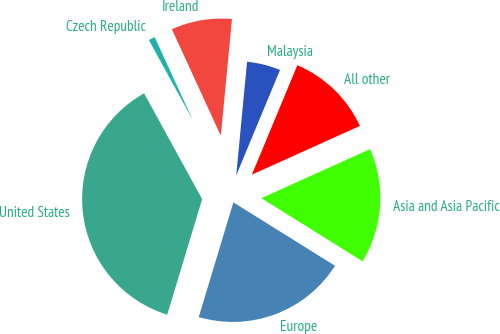<chart> <loc_0><loc_0><loc_500><loc_500><pie_chart><fcel>United States<fcel>Europe<fcel>Asia and Asia Pacific<fcel>All other<fcel>Malaysia<fcel>Ireland<fcel>Czech Republic<nl><fcel>37.34%<fcel>20.79%<fcel>15.62%<fcel>11.99%<fcel>4.75%<fcel>8.37%<fcel>1.13%<nl></chart> 